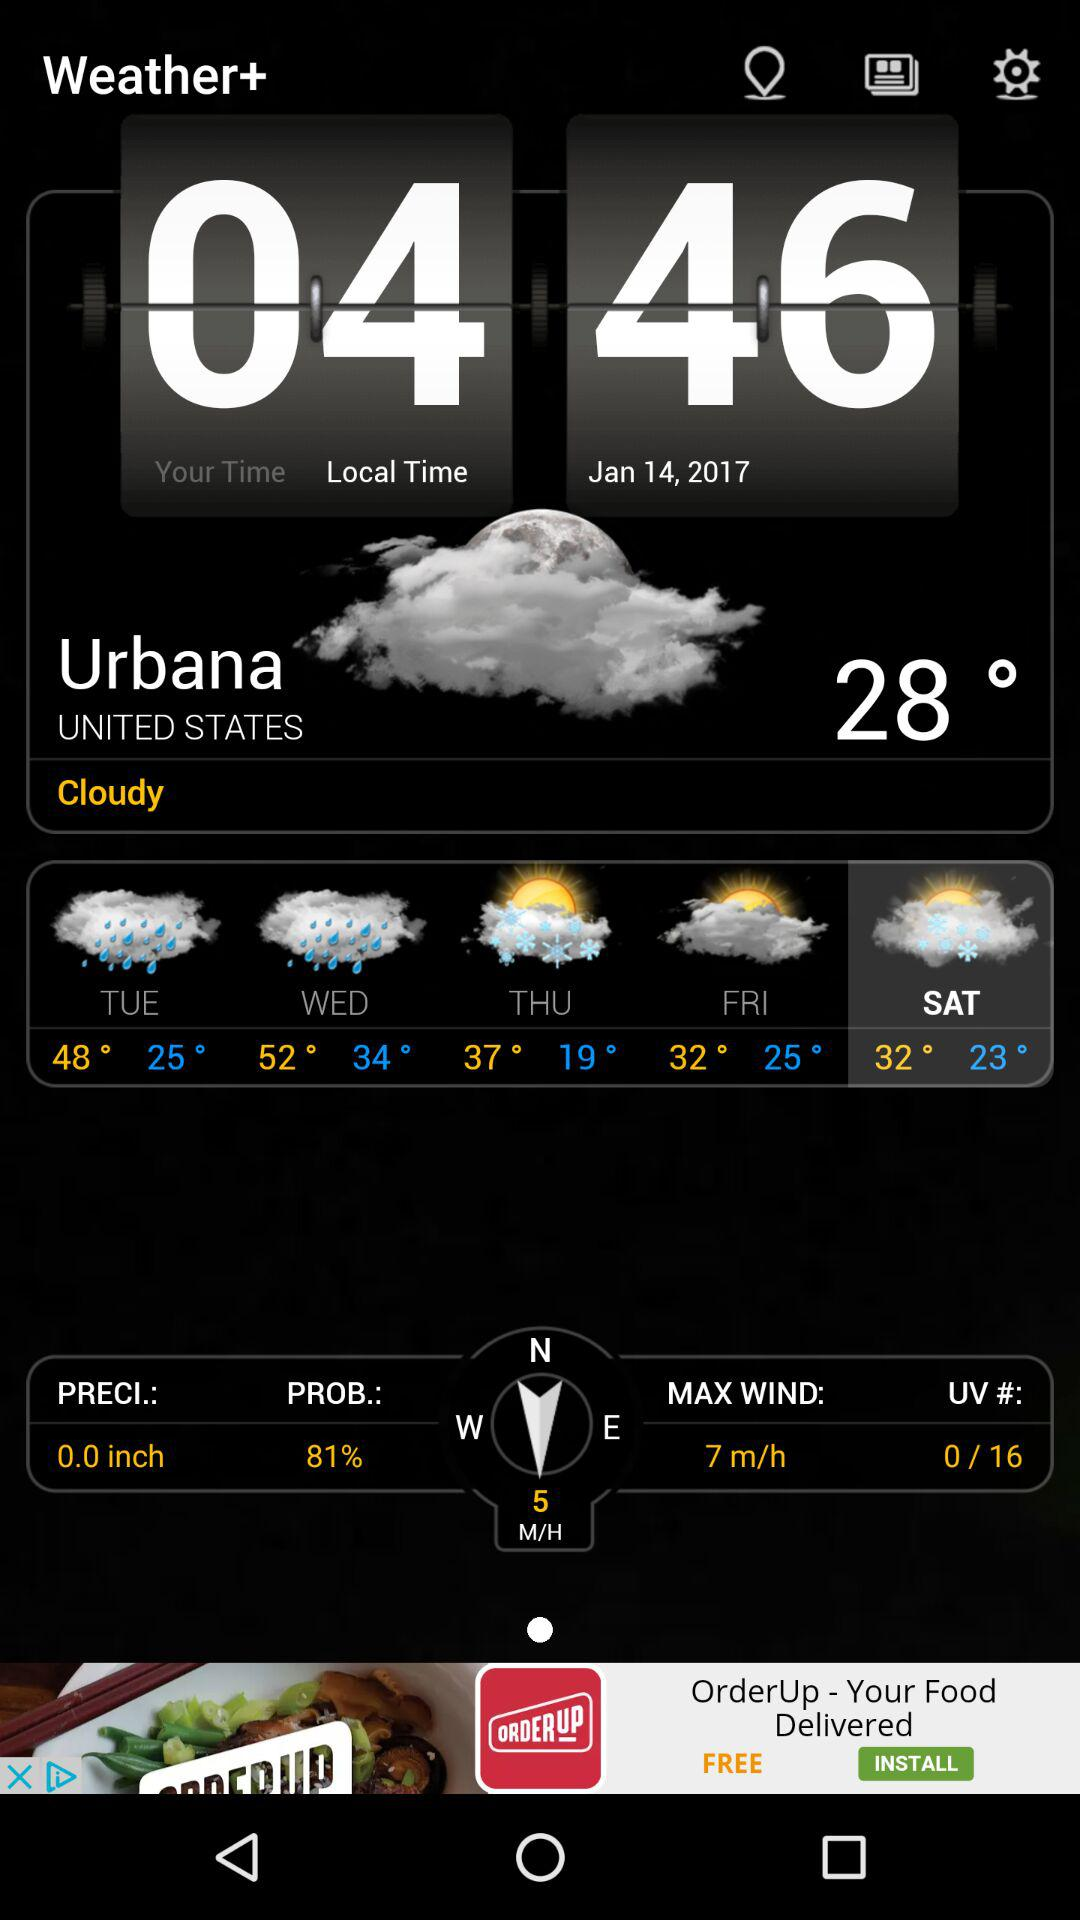What is the humidity for today?
Answer the question using a single word or phrase. 81% 